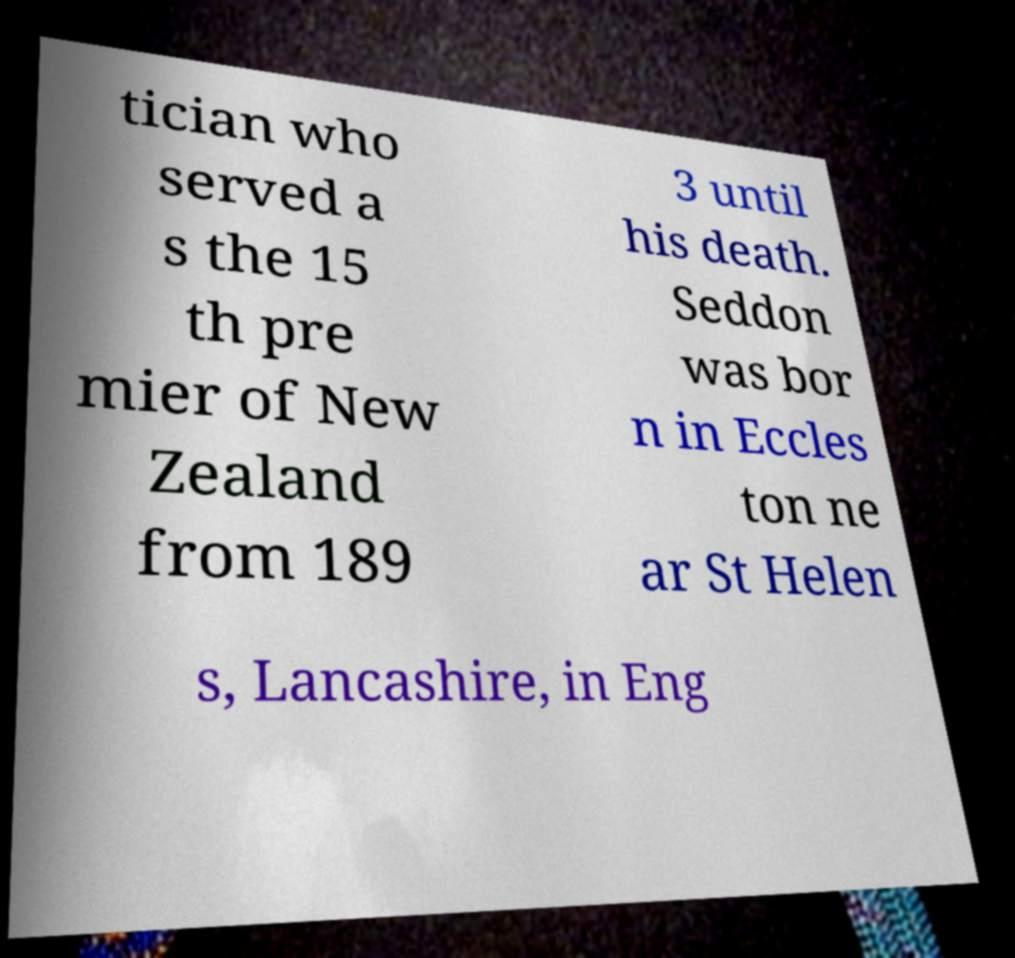I need the written content from this picture converted into text. Can you do that? tician who served a s the 15 th pre mier of New Zealand from 189 3 until his death. Seddon was bor n in Eccles ton ne ar St Helen s, Lancashire, in Eng 